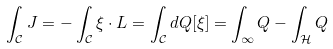<formula> <loc_0><loc_0><loc_500><loc_500>\int _ { \mathcal { C } } J = - \int _ { \mathcal { C } } \xi \cdot L = \int _ { \mathcal { C } } d Q [ \xi ] = \int _ { \infty } Q - \int _ { \mathcal { H } } Q \,</formula> 